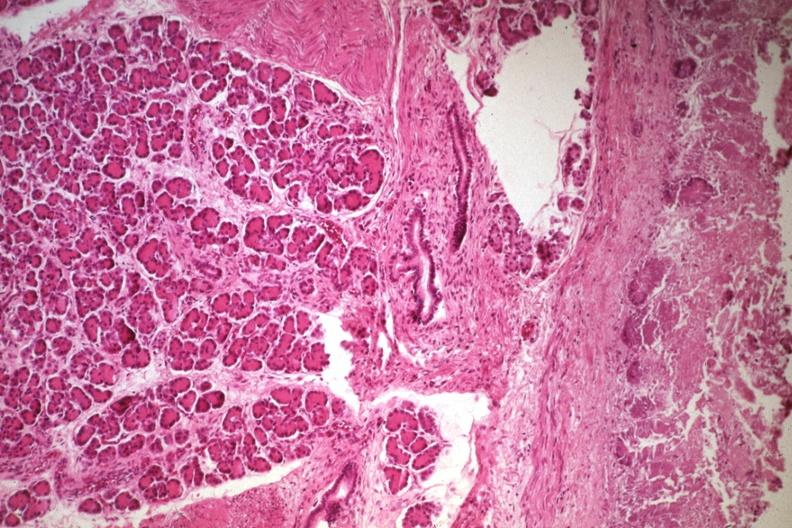s gout present?
Answer the question using a single word or phrase. No 